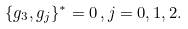<formula> <loc_0><loc_0><loc_500><loc_500>\{ g _ { 3 } , g _ { j } \} ^ { * } = 0 \, , j = 0 , 1 , 2 .</formula> 